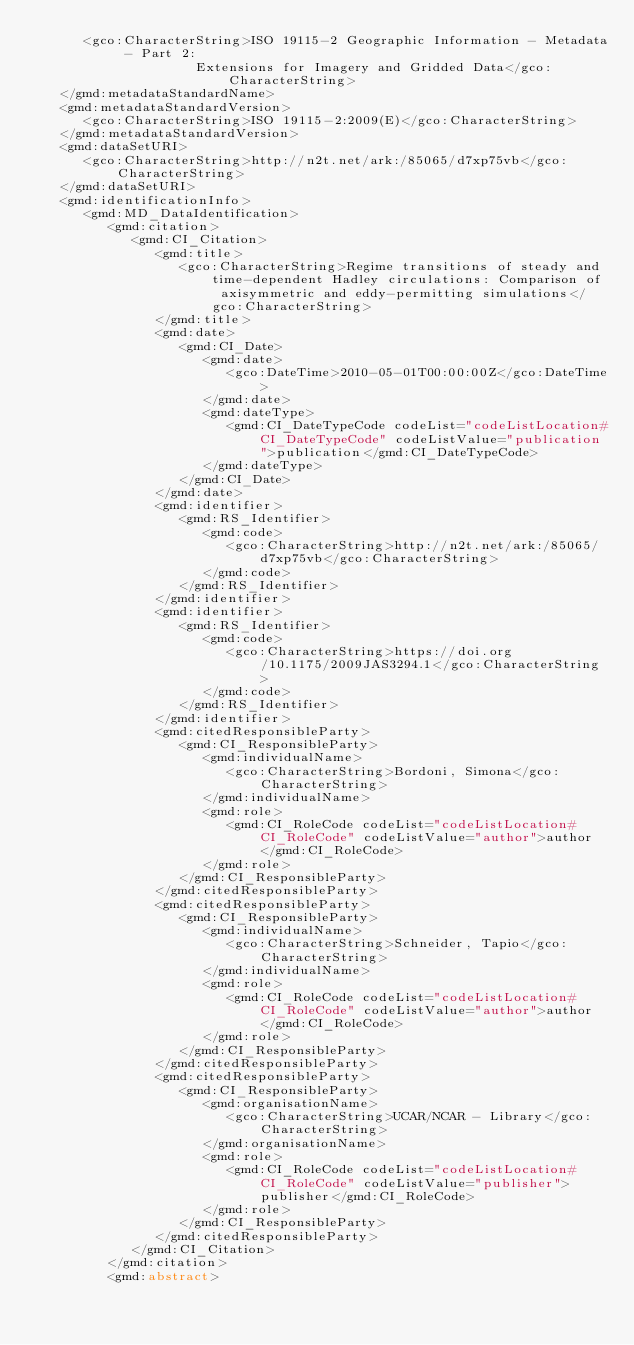<code> <loc_0><loc_0><loc_500><loc_500><_XML_>      <gco:CharacterString>ISO 19115-2 Geographic Information - Metadata - Part 2:
                    Extensions for Imagery and Gridded Data</gco:CharacterString>
   </gmd:metadataStandardName>
   <gmd:metadataStandardVersion>
      <gco:CharacterString>ISO 19115-2:2009(E)</gco:CharacterString>
   </gmd:metadataStandardVersion>
   <gmd:dataSetURI>
      <gco:CharacterString>http://n2t.net/ark:/85065/d7xp75vb</gco:CharacterString>
   </gmd:dataSetURI>
   <gmd:identificationInfo>
      <gmd:MD_DataIdentification>
         <gmd:citation>
            <gmd:CI_Citation>
               <gmd:title>
                  <gco:CharacterString>Regime transitions of steady and time-dependent Hadley circulations: Comparison of axisymmetric and eddy-permitting simulations</gco:CharacterString>
               </gmd:title>
               <gmd:date>
                  <gmd:CI_Date>
                     <gmd:date>
                        <gco:DateTime>2010-05-01T00:00:00Z</gco:DateTime>
                     </gmd:date>
                     <gmd:dateType>
                        <gmd:CI_DateTypeCode codeList="codeListLocation#CI_DateTypeCode" codeListValue="publication">publication</gmd:CI_DateTypeCode>
                     </gmd:dateType>
                  </gmd:CI_Date>
               </gmd:date>
               <gmd:identifier>
                  <gmd:RS_Identifier>
                     <gmd:code>
                        <gco:CharacterString>http://n2t.net/ark:/85065/d7xp75vb</gco:CharacterString>
                     </gmd:code>
                  </gmd:RS_Identifier>
               </gmd:identifier>
               <gmd:identifier>
                  <gmd:RS_Identifier>
                     <gmd:code>
                        <gco:CharacterString>https://doi.org/10.1175/2009JAS3294.1</gco:CharacterString>
                     </gmd:code>
                  </gmd:RS_Identifier>
               </gmd:identifier>
               <gmd:citedResponsibleParty>
                  <gmd:CI_ResponsibleParty>
                     <gmd:individualName>
                        <gco:CharacterString>Bordoni, Simona</gco:CharacterString>
                     </gmd:individualName>
                     <gmd:role>
                        <gmd:CI_RoleCode codeList="codeListLocation#CI_RoleCode" codeListValue="author">author</gmd:CI_RoleCode>
                     </gmd:role>
                  </gmd:CI_ResponsibleParty>
               </gmd:citedResponsibleParty>
               <gmd:citedResponsibleParty>
                  <gmd:CI_ResponsibleParty>
                     <gmd:individualName>
                        <gco:CharacterString>Schneider, Tapio</gco:CharacterString>
                     </gmd:individualName>
                     <gmd:role>
                        <gmd:CI_RoleCode codeList="codeListLocation#CI_RoleCode" codeListValue="author">author</gmd:CI_RoleCode>
                     </gmd:role>
                  </gmd:CI_ResponsibleParty>
               </gmd:citedResponsibleParty>
               <gmd:citedResponsibleParty>
                  <gmd:CI_ResponsibleParty>
                     <gmd:organisationName>
                        <gco:CharacterString>UCAR/NCAR - Library</gco:CharacterString>
                     </gmd:organisationName>
                     <gmd:role>
                        <gmd:CI_RoleCode codeList="codeListLocation#CI_RoleCode" codeListValue="publisher">publisher</gmd:CI_RoleCode>
                     </gmd:role>
                  </gmd:CI_ResponsibleParty>
               </gmd:citedResponsibleParty>
            </gmd:CI_Citation>
         </gmd:citation>
         <gmd:abstract></code> 